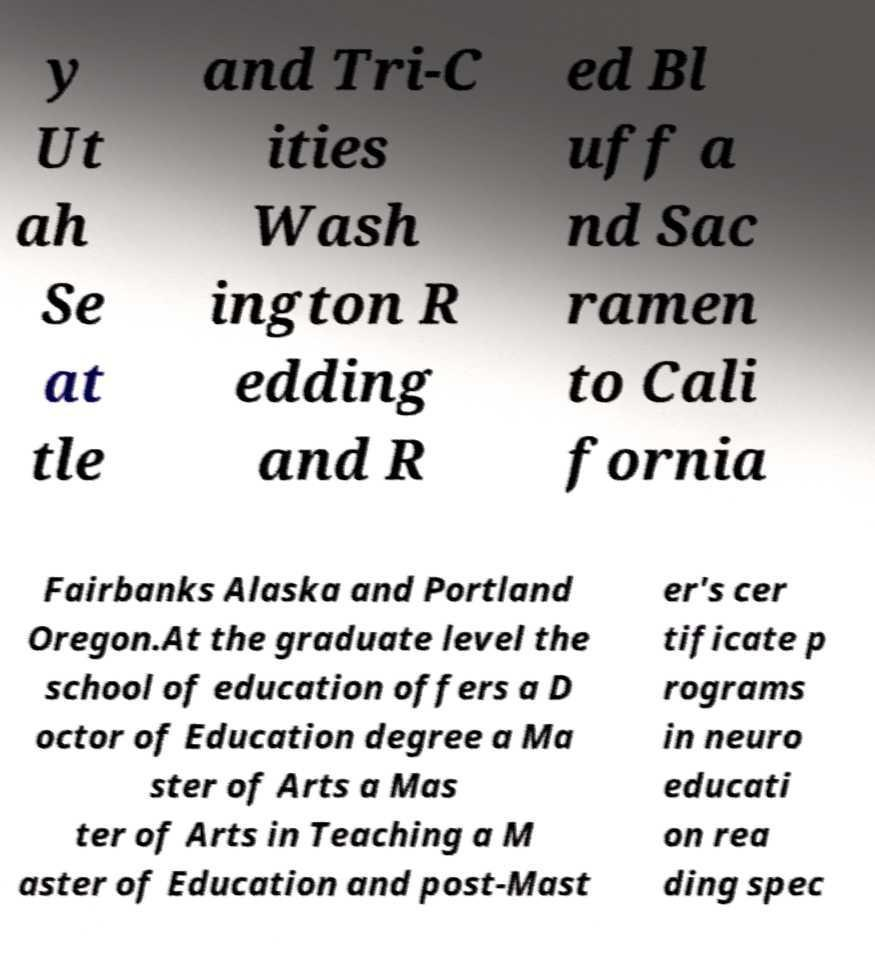Could you extract and type out the text from this image? y Ut ah Se at tle and Tri-C ities Wash ington R edding and R ed Bl uff a nd Sac ramen to Cali fornia Fairbanks Alaska and Portland Oregon.At the graduate level the school of education offers a D octor of Education degree a Ma ster of Arts a Mas ter of Arts in Teaching a M aster of Education and post-Mast er's cer tificate p rograms in neuro educati on rea ding spec 